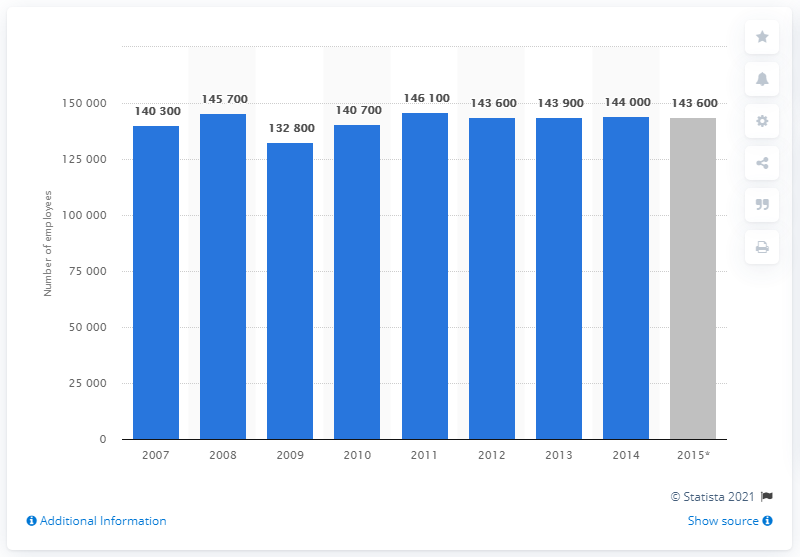Specify some key components in this picture. As of June 2015, approximately 143,600 people were employed in the banking sector in London. In 2014, approximately 143,600 people were employed in the banking sector in London. 